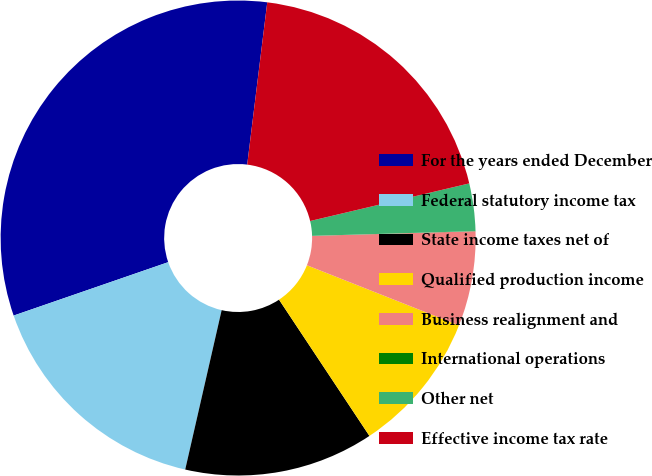Convert chart. <chart><loc_0><loc_0><loc_500><loc_500><pie_chart><fcel>For the years ended December<fcel>Federal statutory income tax<fcel>State income taxes net of<fcel>Qualified production income<fcel>Business realignment and<fcel>International operations<fcel>Other net<fcel>Effective income tax rate<nl><fcel>32.25%<fcel>16.13%<fcel>12.9%<fcel>9.68%<fcel>6.45%<fcel>0.01%<fcel>3.23%<fcel>19.35%<nl></chart> 